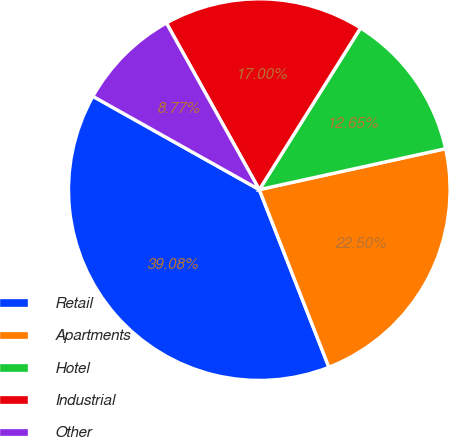Convert chart. <chart><loc_0><loc_0><loc_500><loc_500><pie_chart><fcel>Retail<fcel>Apartments<fcel>Hotel<fcel>Industrial<fcel>Other<nl><fcel>39.08%<fcel>22.5%<fcel>12.65%<fcel>17.0%<fcel>8.77%<nl></chart> 